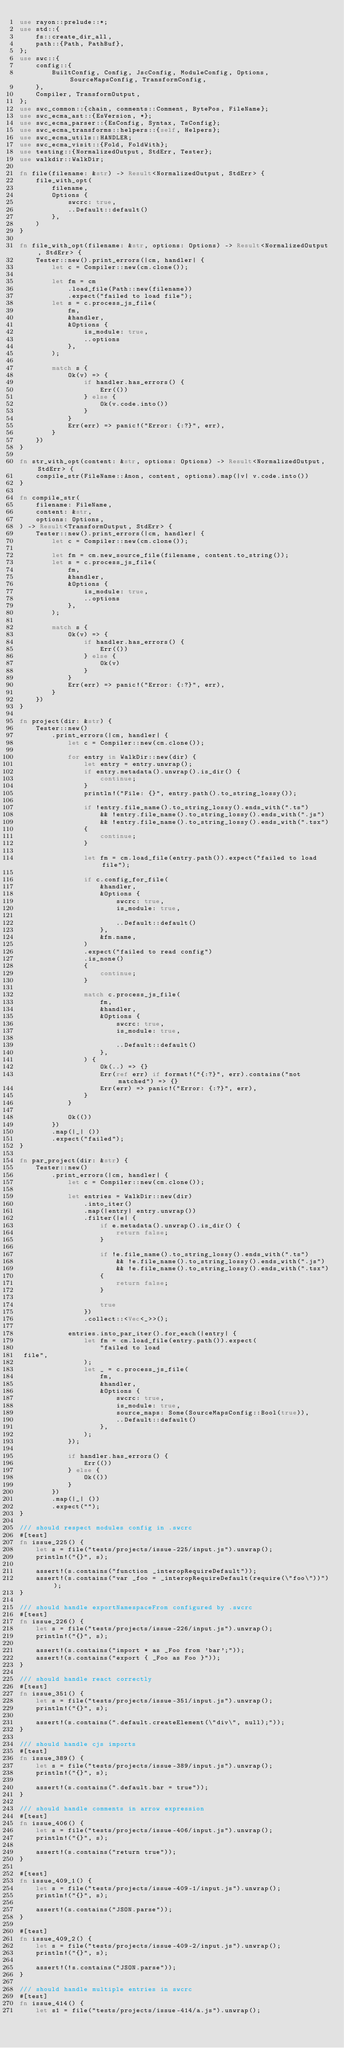<code> <loc_0><loc_0><loc_500><loc_500><_Rust_>use rayon::prelude::*;
use std::{
    fs::create_dir_all,
    path::{Path, PathBuf},
};
use swc::{
    config::{
        BuiltConfig, Config, JscConfig, ModuleConfig, Options, SourceMapsConfig, TransformConfig,
    },
    Compiler, TransformOutput,
};
use swc_common::{chain, comments::Comment, BytePos, FileName};
use swc_ecma_ast::{EsVersion, *};
use swc_ecma_parser::{EsConfig, Syntax, TsConfig};
use swc_ecma_transforms::helpers::{self, Helpers};
use swc_ecma_utils::HANDLER;
use swc_ecma_visit::{Fold, FoldWith};
use testing::{NormalizedOutput, StdErr, Tester};
use walkdir::WalkDir;

fn file(filename: &str) -> Result<NormalizedOutput, StdErr> {
    file_with_opt(
        filename,
        Options {
            swcrc: true,
            ..Default::default()
        },
    )
}

fn file_with_opt(filename: &str, options: Options) -> Result<NormalizedOutput, StdErr> {
    Tester::new().print_errors(|cm, handler| {
        let c = Compiler::new(cm.clone());

        let fm = cm
            .load_file(Path::new(filename))
            .expect("failed to load file");
        let s = c.process_js_file(
            fm,
            &handler,
            &Options {
                is_module: true,
                ..options
            },
        );

        match s {
            Ok(v) => {
                if handler.has_errors() {
                    Err(())
                } else {
                    Ok(v.code.into())
                }
            }
            Err(err) => panic!("Error: {:?}", err),
        }
    })
}

fn str_with_opt(content: &str, options: Options) -> Result<NormalizedOutput, StdErr> {
    compile_str(FileName::Anon, content, options).map(|v| v.code.into())
}

fn compile_str(
    filename: FileName,
    content: &str,
    options: Options,
) -> Result<TransformOutput, StdErr> {
    Tester::new().print_errors(|cm, handler| {
        let c = Compiler::new(cm.clone());

        let fm = cm.new_source_file(filename, content.to_string());
        let s = c.process_js_file(
            fm,
            &handler,
            &Options {
                is_module: true,
                ..options
            },
        );

        match s {
            Ok(v) => {
                if handler.has_errors() {
                    Err(())
                } else {
                    Ok(v)
                }
            }
            Err(err) => panic!("Error: {:?}", err),
        }
    })
}

fn project(dir: &str) {
    Tester::new()
        .print_errors(|cm, handler| {
            let c = Compiler::new(cm.clone());

            for entry in WalkDir::new(dir) {
                let entry = entry.unwrap();
                if entry.metadata().unwrap().is_dir() {
                    continue;
                }
                println!("File: {}", entry.path().to_string_lossy());

                if !entry.file_name().to_string_lossy().ends_with(".ts")
                    && !entry.file_name().to_string_lossy().ends_with(".js")
                    && !entry.file_name().to_string_lossy().ends_with(".tsx")
                {
                    continue;
                }

                let fm = cm.load_file(entry.path()).expect("failed to load file");

                if c.config_for_file(
                    &handler,
                    &Options {
                        swcrc: true,
                        is_module: true,

                        ..Default::default()
                    },
                    &fm.name,
                )
                .expect("failed to read config")
                .is_none()
                {
                    continue;
                }

                match c.process_js_file(
                    fm,
                    &handler,
                    &Options {
                        swcrc: true,
                        is_module: true,

                        ..Default::default()
                    },
                ) {
                    Ok(..) => {}
                    Err(ref err) if format!("{:?}", err).contains("not matched") => {}
                    Err(err) => panic!("Error: {:?}", err),
                }
            }

            Ok(())
        })
        .map(|_| ())
        .expect("failed");
}

fn par_project(dir: &str) {
    Tester::new()
        .print_errors(|cm, handler| {
            let c = Compiler::new(cm.clone());

            let entries = WalkDir::new(dir)
                .into_iter()
                .map(|entry| entry.unwrap())
                .filter(|e| {
                    if e.metadata().unwrap().is_dir() {
                        return false;
                    }

                    if !e.file_name().to_string_lossy().ends_with(".ts")
                        && !e.file_name().to_string_lossy().ends_with(".js")
                        && !e.file_name().to_string_lossy().ends_with(".tsx")
                    {
                        return false;
                    }

                    true
                })
                .collect::<Vec<_>>();

            entries.into_par_iter().for_each(|entry| {
                let fm = cm.load_file(entry.path()).expect(
                    "failed to load
 file",
                );
                let _ = c.process_js_file(
                    fm,
                    &handler,
                    &Options {
                        swcrc: true,
                        is_module: true,
                        source_maps: Some(SourceMapsConfig::Bool(true)),
                        ..Default::default()
                    },
                );
            });

            if handler.has_errors() {
                Err(())
            } else {
                Ok(())
            }
        })
        .map(|_| ())
        .expect("");
}

/// should respect modules config in .swcrc
#[test]
fn issue_225() {
    let s = file("tests/projects/issue-225/input.js").unwrap();
    println!("{}", s);

    assert!(s.contains("function _interopRequireDefault"));
    assert!(s.contains("var _foo = _interopRequireDefault(require(\"foo\"))"));
}

/// should handle exportNamespaceFrom configured by .swcrc
#[test]
fn issue_226() {
    let s = file("tests/projects/issue-226/input.js").unwrap();
    println!("{}", s);

    assert!(s.contains("import * as _Foo from 'bar';"));
    assert!(s.contains("export { _Foo as Foo }"));
}

/// should handle react correctly
#[test]
fn issue_351() {
    let s = file("tests/projects/issue-351/input.js").unwrap();
    println!("{}", s);

    assert!(s.contains(".default.createElement(\"div\", null);"));
}

/// should handle cjs imports
#[test]
fn issue_389() {
    let s = file("tests/projects/issue-389/input.js").unwrap();
    println!("{}", s);

    assert!(s.contains(".default.bar = true"));
}

/// should handle comments in arrow expression
#[test]
fn issue_406() {
    let s = file("tests/projects/issue-406/input.js").unwrap();
    println!("{}", s);

    assert!(s.contains("return true"));
}

#[test]
fn issue_409_1() {
    let s = file("tests/projects/issue-409-1/input.js").unwrap();
    println!("{}", s);

    assert!(s.contains("JSON.parse"));
}

#[test]
fn issue_409_2() {
    let s = file("tests/projects/issue-409-2/input.js").unwrap();
    println!("{}", s);

    assert!(!s.contains("JSON.parse"));
}

/// should handle multiple entries in swcrc
#[test]
fn issue_414() {
    let s1 = file("tests/projects/issue-414/a.js").unwrap();</code> 